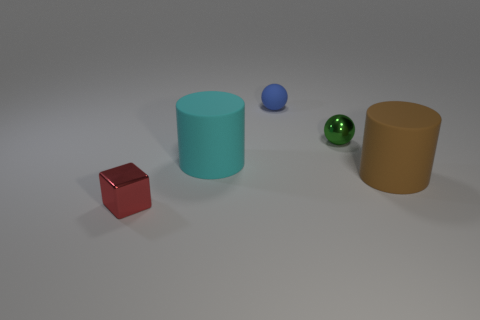Are there an equal number of cyan matte things that are right of the blue ball and objects that are behind the small cube?
Keep it short and to the point. No. The metallic thing that is right of the object in front of the big rubber thing right of the cyan matte cylinder is what shape?
Your answer should be compact. Sphere. Is the material of the thing behind the green thing the same as the large object to the right of the green object?
Keep it short and to the point. Yes. There is a metal object that is behind the red shiny block; what is its shape?
Provide a succinct answer. Sphere. Are there fewer brown objects than tiny cylinders?
Provide a succinct answer. No. Are there any small objects that are to the right of the metal object that is on the right side of the cube that is left of the tiny green shiny ball?
Ensure brevity in your answer.  No. How many metallic things are either blue objects or red spheres?
Offer a very short reply. 0. There is a small blue thing; how many tiny things are to the left of it?
Your response must be concise. 1. What number of objects are on the right side of the red thing and in front of the large cyan rubber cylinder?
Your response must be concise. 1. The tiny thing that is the same material as the brown cylinder is what shape?
Provide a short and direct response. Sphere. 